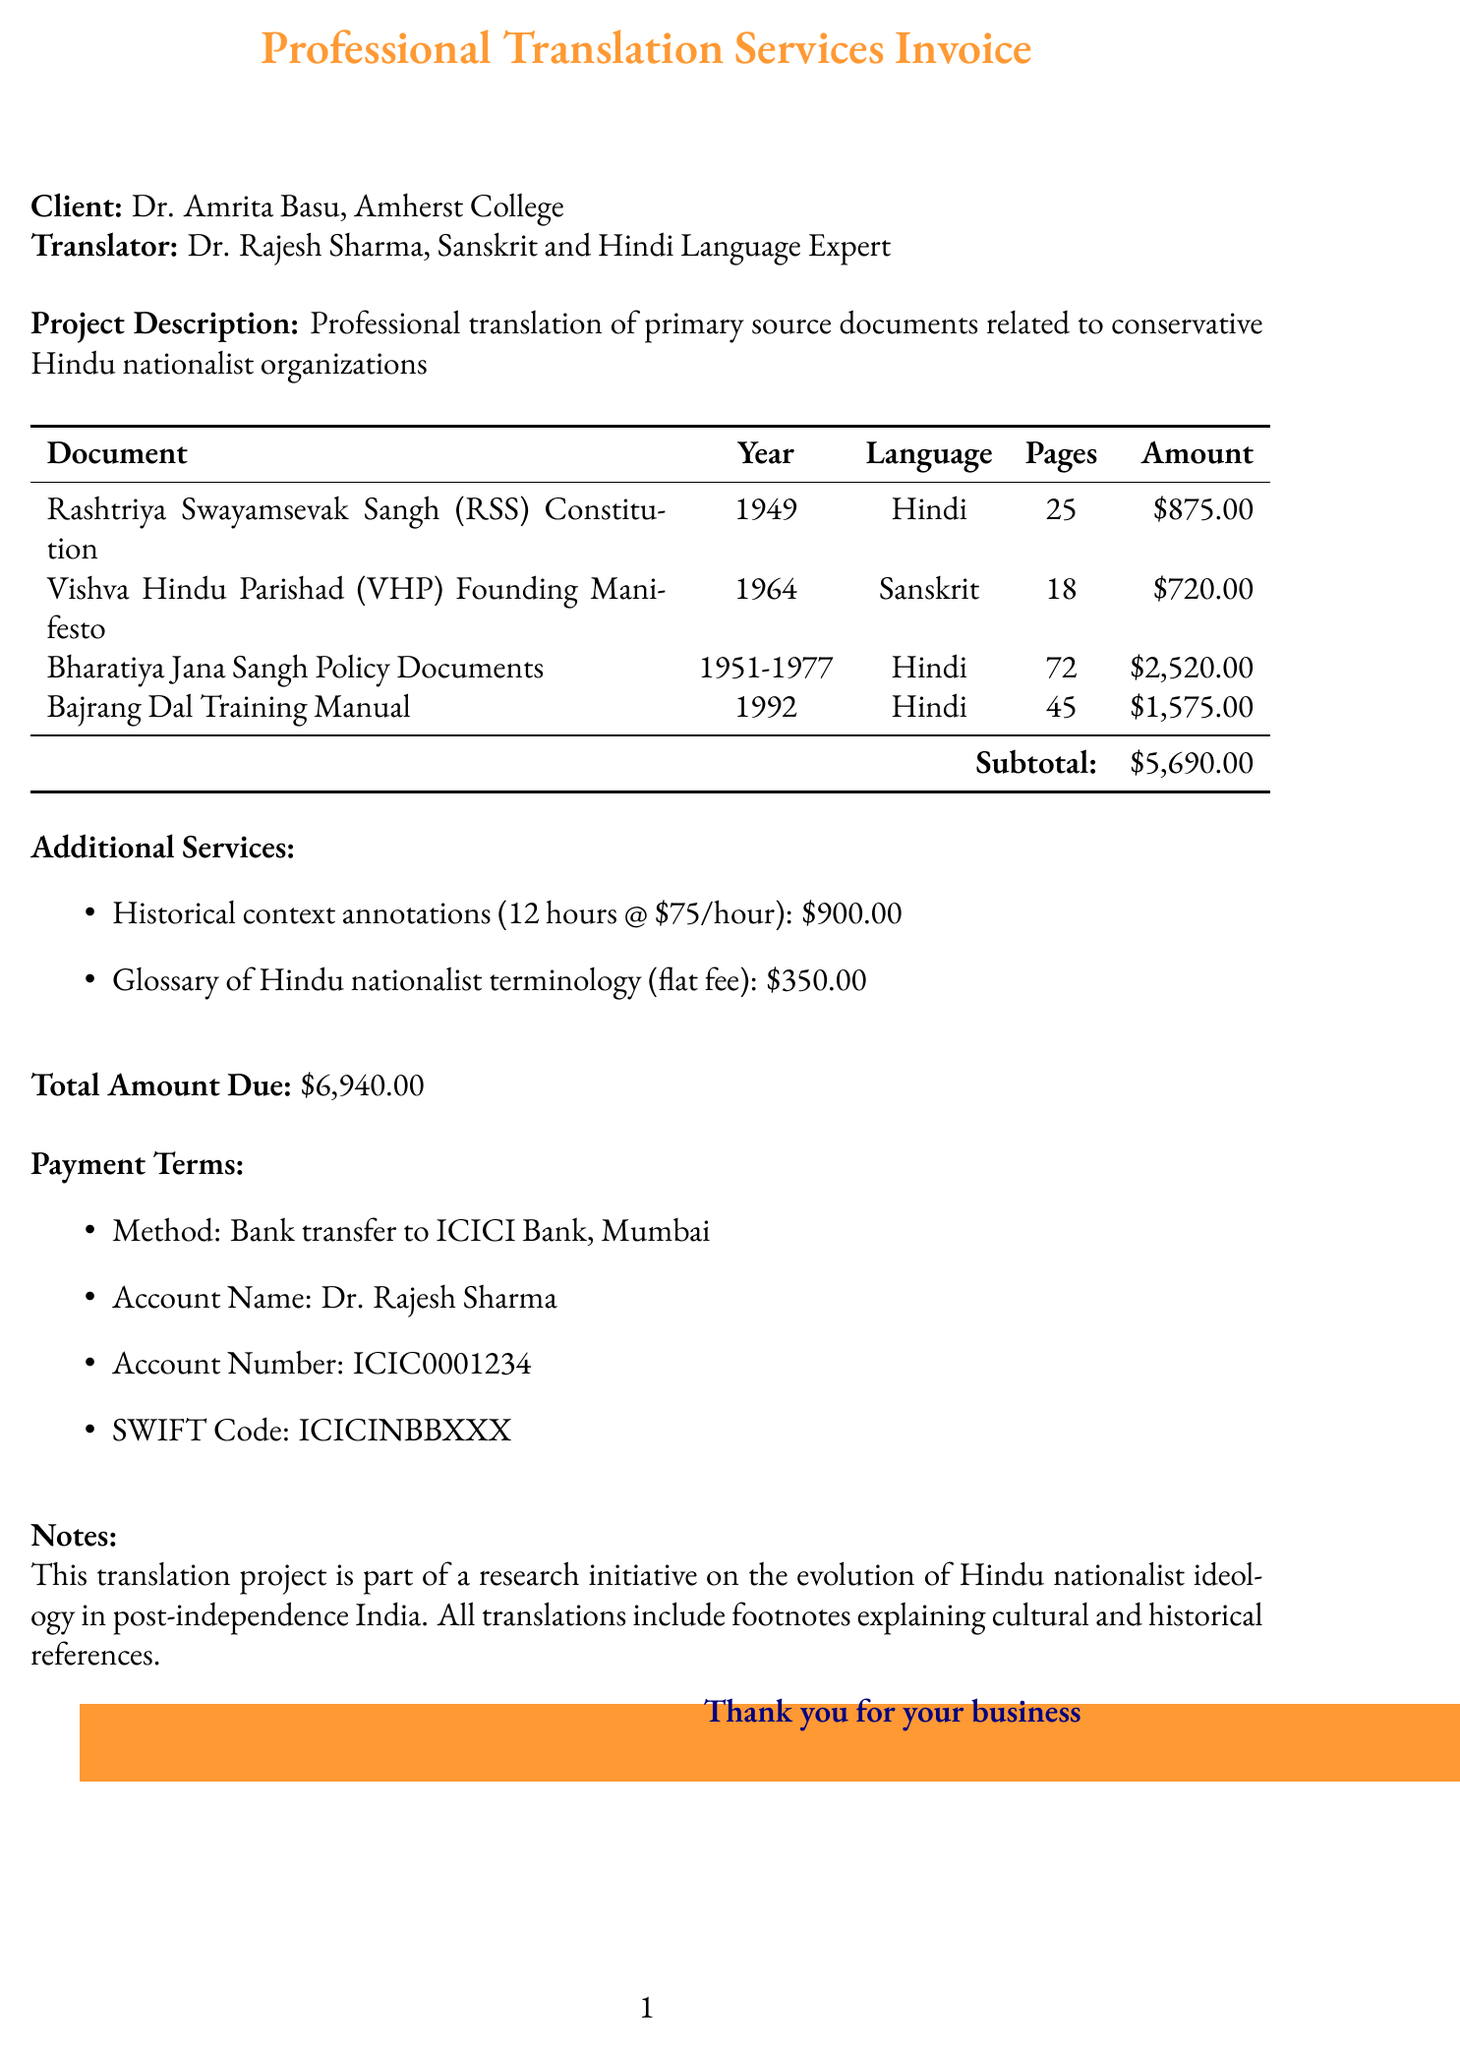What is the invoice number? The invoice number is provided at the top of the document for reference.
Answer: INV-2023-0542 Who is the translator? The document specifies the translator's name along with their expertise.
Answer: Dr. Rajesh Sharma What is the total amount due? The total amount calculated from services provided is mentioned at the end of the document.
Answer: $6,940.00 How many pages are in the Bajrang Dal Training Manual? The document lists the number of pages for each source document, including this one.
Answer: 45 What is the rate per page for the Vishva Hindu Parishad (VHP) Founding Manifesto? The document details the rate for each source document by language and type.
Answer: $40 What service costs a flat fee? The invoice includes additional services with different pricing models, clearly indicating any flat fees.
Answer: Glossary of Hindu nationalist terminology What is the payment method specified? The document outlines how the payment should be processed, including bank details.
Answer: Bank transfer to ICICI Bank, Mumbai How many hours were billed for historical context annotations? The document specifies the number of hours billed for that particular additional service.
Answer: 12 What is included in the notes section? The notes section provides context and details about the purpose of the translation project.
Answer: Research initiative on the evolution of Hindu nationalist ideology in post-independence India 